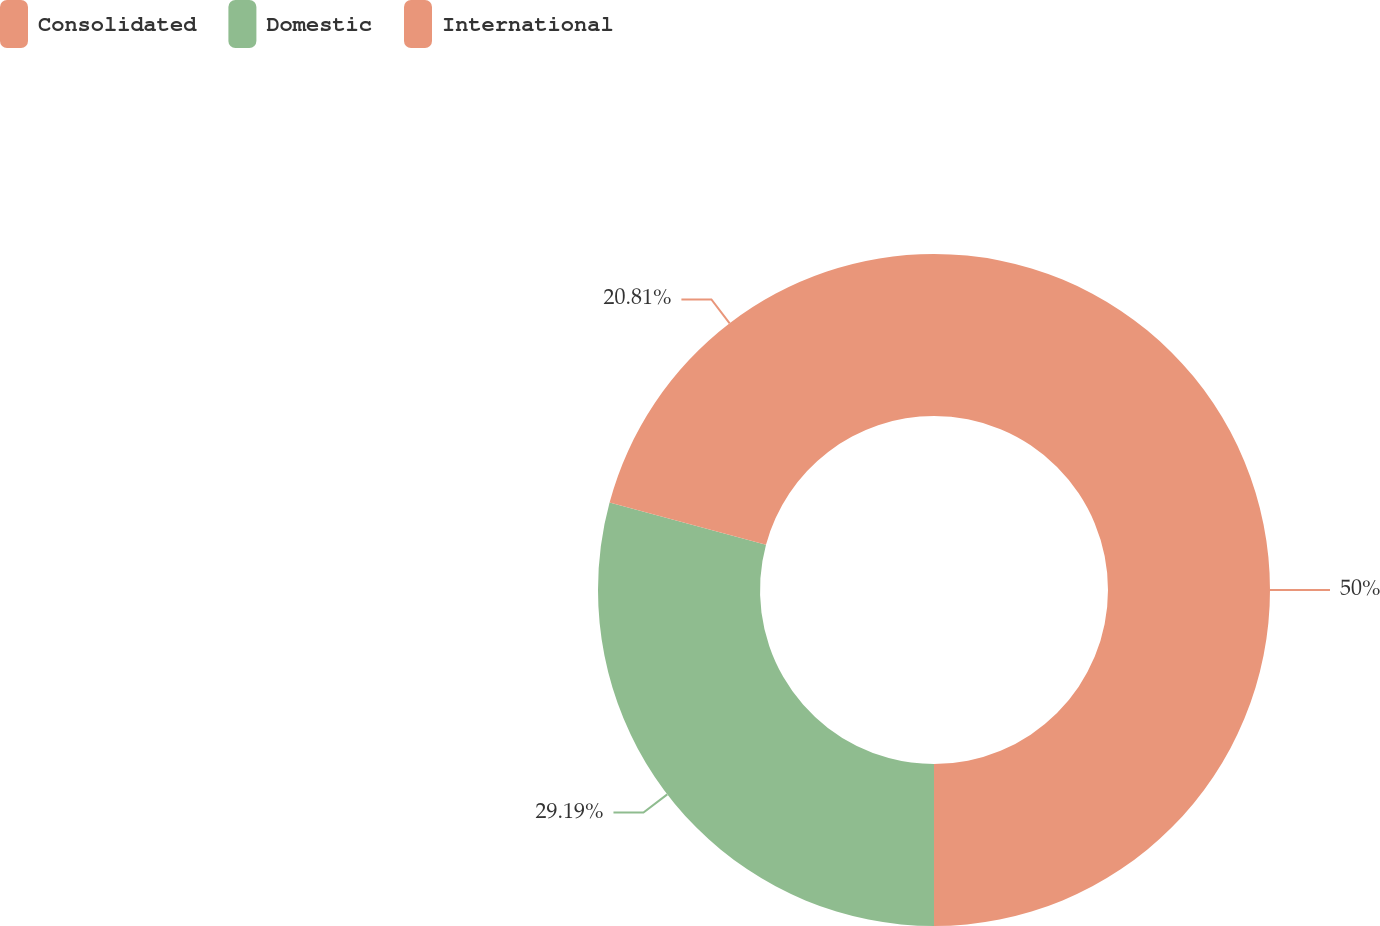Convert chart. <chart><loc_0><loc_0><loc_500><loc_500><pie_chart><fcel>Consolidated<fcel>Domestic<fcel>International<nl><fcel>50.0%<fcel>29.19%<fcel>20.81%<nl></chart> 